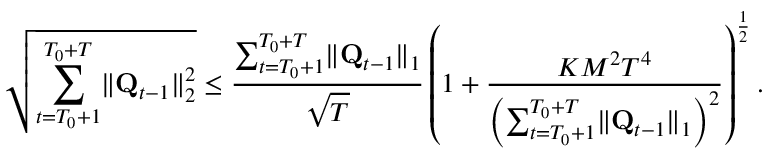Convert formula to latex. <formula><loc_0><loc_0><loc_500><loc_500>\sqrt { \sum _ { t = T _ { 0 } + 1 } ^ { T _ { 0 } + T } \| \mathbf Q _ { t - 1 } \| _ { 2 } ^ { 2 } } \leq \frac { \sum _ { t = T _ { 0 } + 1 } ^ { T _ { 0 } + T } \| \mathbf Q _ { t - 1 } \| _ { 1 } } { \sqrt { T } } \left ( 1 + \frac { K M ^ { 2 } T ^ { 4 } } { \left ( \sum _ { t = T _ { 0 } + 1 } ^ { T _ { 0 } + T } \| \mathbf Q _ { t - 1 } \| _ { 1 } \right ) ^ { 2 } } \right ) ^ { \frac { 1 } { 2 } } .</formula> 